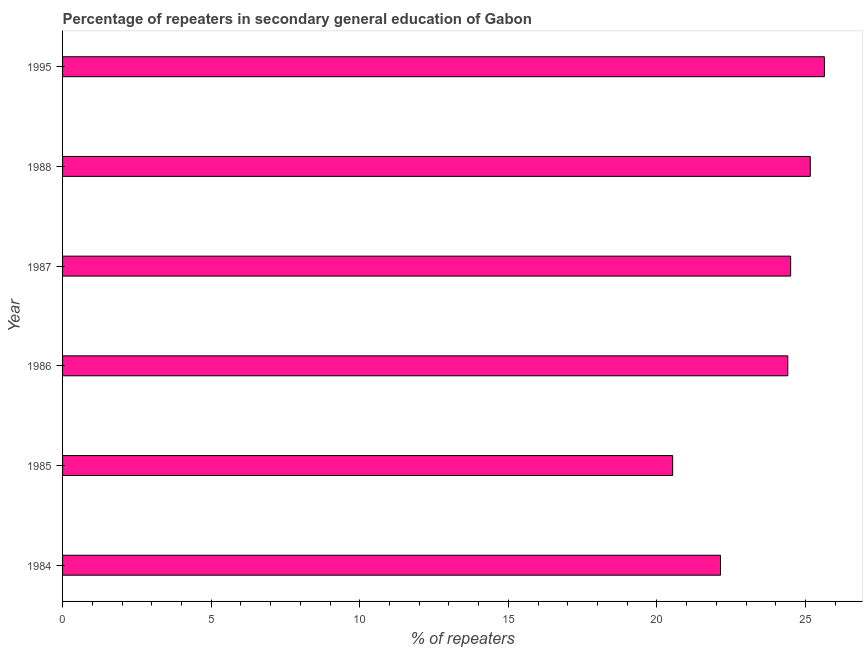Does the graph contain any zero values?
Your answer should be compact. No. What is the title of the graph?
Ensure brevity in your answer.  Percentage of repeaters in secondary general education of Gabon. What is the label or title of the X-axis?
Offer a terse response. % of repeaters. What is the percentage of repeaters in 1986?
Offer a very short reply. 24.41. Across all years, what is the maximum percentage of repeaters?
Provide a succinct answer. 25.64. Across all years, what is the minimum percentage of repeaters?
Provide a succinct answer. 20.53. In which year was the percentage of repeaters maximum?
Give a very brief answer. 1995. In which year was the percentage of repeaters minimum?
Offer a terse response. 1985. What is the sum of the percentage of repeaters?
Offer a very short reply. 142.38. What is the difference between the percentage of repeaters in 1984 and 1988?
Provide a succinct answer. -3.02. What is the average percentage of repeaters per year?
Your answer should be compact. 23.73. What is the median percentage of repeaters?
Ensure brevity in your answer.  24.45. In how many years, is the percentage of repeaters greater than 2 %?
Ensure brevity in your answer.  6. Do a majority of the years between 1985 and 1988 (inclusive) have percentage of repeaters greater than 23 %?
Provide a short and direct response. Yes. What is the ratio of the percentage of repeaters in 1987 to that in 1995?
Your answer should be compact. 0.96. What is the difference between the highest and the second highest percentage of repeaters?
Give a very brief answer. 0.47. What is the difference between the highest and the lowest percentage of repeaters?
Make the answer very short. 5.11. How many bars are there?
Make the answer very short. 6. Are all the bars in the graph horizontal?
Your answer should be very brief. Yes. What is the difference between two consecutive major ticks on the X-axis?
Offer a very short reply. 5. Are the values on the major ticks of X-axis written in scientific E-notation?
Ensure brevity in your answer.  No. What is the % of repeaters in 1984?
Your response must be concise. 22.14. What is the % of repeaters in 1985?
Give a very brief answer. 20.53. What is the % of repeaters of 1986?
Keep it short and to the point. 24.41. What is the % of repeaters in 1987?
Your response must be concise. 24.5. What is the % of repeaters of 1988?
Your answer should be compact. 25.16. What is the % of repeaters in 1995?
Offer a terse response. 25.64. What is the difference between the % of repeaters in 1984 and 1985?
Provide a short and direct response. 1.61. What is the difference between the % of repeaters in 1984 and 1986?
Keep it short and to the point. -2.26. What is the difference between the % of repeaters in 1984 and 1987?
Ensure brevity in your answer.  -2.36. What is the difference between the % of repeaters in 1984 and 1988?
Provide a succinct answer. -3.02. What is the difference between the % of repeaters in 1984 and 1995?
Offer a terse response. -3.5. What is the difference between the % of repeaters in 1985 and 1986?
Provide a succinct answer. -3.87. What is the difference between the % of repeaters in 1985 and 1987?
Ensure brevity in your answer.  -3.97. What is the difference between the % of repeaters in 1985 and 1988?
Give a very brief answer. -4.63. What is the difference between the % of repeaters in 1985 and 1995?
Give a very brief answer. -5.11. What is the difference between the % of repeaters in 1986 and 1987?
Provide a succinct answer. -0.1. What is the difference between the % of repeaters in 1986 and 1988?
Provide a short and direct response. -0.76. What is the difference between the % of repeaters in 1986 and 1995?
Your answer should be compact. -1.23. What is the difference between the % of repeaters in 1987 and 1988?
Keep it short and to the point. -0.66. What is the difference between the % of repeaters in 1987 and 1995?
Your response must be concise. -1.14. What is the difference between the % of repeaters in 1988 and 1995?
Your answer should be compact. -0.47. What is the ratio of the % of repeaters in 1984 to that in 1985?
Provide a succinct answer. 1.08. What is the ratio of the % of repeaters in 1984 to that in 1986?
Offer a very short reply. 0.91. What is the ratio of the % of repeaters in 1984 to that in 1987?
Your answer should be very brief. 0.9. What is the ratio of the % of repeaters in 1984 to that in 1995?
Make the answer very short. 0.86. What is the ratio of the % of repeaters in 1985 to that in 1986?
Provide a short and direct response. 0.84. What is the ratio of the % of repeaters in 1985 to that in 1987?
Your response must be concise. 0.84. What is the ratio of the % of repeaters in 1985 to that in 1988?
Keep it short and to the point. 0.82. What is the ratio of the % of repeaters in 1985 to that in 1995?
Your response must be concise. 0.8. What is the ratio of the % of repeaters in 1986 to that in 1987?
Give a very brief answer. 1. What is the ratio of the % of repeaters in 1986 to that in 1988?
Provide a short and direct response. 0.97. What is the ratio of the % of repeaters in 1986 to that in 1995?
Keep it short and to the point. 0.95. What is the ratio of the % of repeaters in 1987 to that in 1995?
Your answer should be very brief. 0.96. 